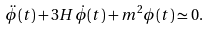Convert formula to latex. <formula><loc_0><loc_0><loc_500><loc_500>\ddot { \phi } ( t ) + 3 H \dot { \phi } ( t ) + m ^ { 2 } \phi ( t ) \simeq 0 .</formula> 